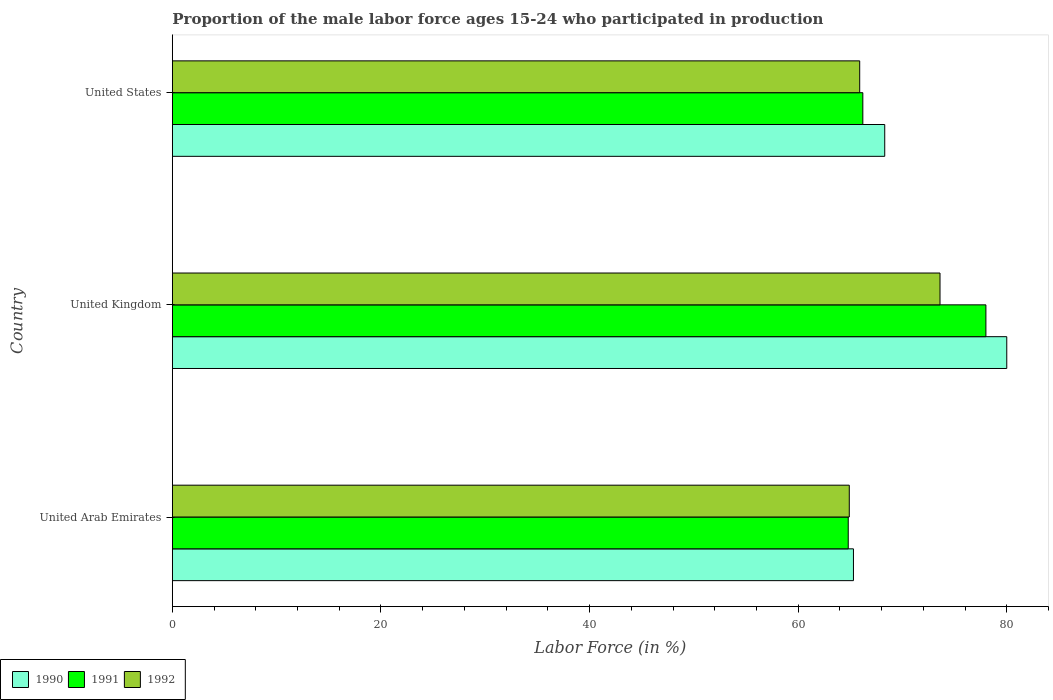How many different coloured bars are there?
Make the answer very short. 3. How many groups of bars are there?
Provide a succinct answer. 3. Are the number of bars per tick equal to the number of legend labels?
Provide a short and direct response. Yes. Are the number of bars on each tick of the Y-axis equal?
Provide a succinct answer. Yes. How many bars are there on the 3rd tick from the top?
Your answer should be compact. 3. What is the label of the 2nd group of bars from the top?
Provide a short and direct response. United Kingdom. In how many cases, is the number of bars for a given country not equal to the number of legend labels?
Provide a short and direct response. 0. Across all countries, what is the maximum proportion of the male labor force who participated in production in 1991?
Give a very brief answer. 78. Across all countries, what is the minimum proportion of the male labor force who participated in production in 1990?
Keep it short and to the point. 65.3. In which country was the proportion of the male labor force who participated in production in 1992 minimum?
Ensure brevity in your answer.  United Arab Emirates. What is the total proportion of the male labor force who participated in production in 1990 in the graph?
Your answer should be compact. 213.6. What is the difference between the proportion of the male labor force who participated in production in 1991 in United Arab Emirates and that in United States?
Provide a succinct answer. -1.4. What is the difference between the proportion of the male labor force who participated in production in 1991 in United Kingdom and the proportion of the male labor force who participated in production in 1992 in United States?
Your answer should be compact. 12.1. What is the average proportion of the male labor force who participated in production in 1992 per country?
Provide a succinct answer. 68.13. What is the difference between the proportion of the male labor force who participated in production in 1992 and proportion of the male labor force who participated in production in 1991 in United States?
Your response must be concise. -0.3. What is the ratio of the proportion of the male labor force who participated in production in 1990 in United Arab Emirates to that in United Kingdom?
Ensure brevity in your answer.  0.82. Is the difference between the proportion of the male labor force who participated in production in 1992 in United Arab Emirates and United States greater than the difference between the proportion of the male labor force who participated in production in 1991 in United Arab Emirates and United States?
Offer a very short reply. Yes. What is the difference between the highest and the second highest proportion of the male labor force who participated in production in 1991?
Provide a short and direct response. 11.8. What is the difference between the highest and the lowest proportion of the male labor force who participated in production in 1991?
Offer a very short reply. 13.2. What does the 1st bar from the bottom in United Arab Emirates represents?
Offer a terse response. 1990. Is it the case that in every country, the sum of the proportion of the male labor force who participated in production in 1992 and proportion of the male labor force who participated in production in 1990 is greater than the proportion of the male labor force who participated in production in 1991?
Your answer should be very brief. Yes. Are all the bars in the graph horizontal?
Offer a very short reply. Yes. What is the difference between two consecutive major ticks on the X-axis?
Your response must be concise. 20. Are the values on the major ticks of X-axis written in scientific E-notation?
Your response must be concise. No. Does the graph contain any zero values?
Provide a succinct answer. No. Does the graph contain grids?
Your answer should be compact. No. Where does the legend appear in the graph?
Ensure brevity in your answer.  Bottom left. How many legend labels are there?
Keep it short and to the point. 3. What is the title of the graph?
Keep it short and to the point. Proportion of the male labor force ages 15-24 who participated in production. What is the label or title of the X-axis?
Provide a succinct answer. Labor Force (in %). What is the label or title of the Y-axis?
Provide a short and direct response. Country. What is the Labor Force (in %) in 1990 in United Arab Emirates?
Make the answer very short. 65.3. What is the Labor Force (in %) of 1991 in United Arab Emirates?
Your response must be concise. 64.8. What is the Labor Force (in %) in 1992 in United Arab Emirates?
Your answer should be compact. 64.9. What is the Labor Force (in %) in 1991 in United Kingdom?
Your answer should be compact. 78. What is the Labor Force (in %) in 1992 in United Kingdom?
Your answer should be compact. 73.6. What is the Labor Force (in %) in 1990 in United States?
Your response must be concise. 68.3. What is the Labor Force (in %) of 1991 in United States?
Keep it short and to the point. 66.2. What is the Labor Force (in %) of 1992 in United States?
Provide a short and direct response. 65.9. Across all countries, what is the maximum Labor Force (in %) in 1992?
Provide a succinct answer. 73.6. Across all countries, what is the minimum Labor Force (in %) in 1990?
Offer a very short reply. 65.3. Across all countries, what is the minimum Labor Force (in %) of 1991?
Provide a succinct answer. 64.8. Across all countries, what is the minimum Labor Force (in %) of 1992?
Your answer should be compact. 64.9. What is the total Labor Force (in %) in 1990 in the graph?
Keep it short and to the point. 213.6. What is the total Labor Force (in %) in 1991 in the graph?
Provide a succinct answer. 209. What is the total Labor Force (in %) of 1992 in the graph?
Keep it short and to the point. 204.4. What is the difference between the Labor Force (in %) of 1990 in United Arab Emirates and that in United Kingdom?
Make the answer very short. -14.7. What is the difference between the Labor Force (in %) of 1991 in United Arab Emirates and that in United Kingdom?
Give a very brief answer. -13.2. What is the difference between the Labor Force (in %) of 1991 in United Kingdom and that in United States?
Give a very brief answer. 11.8. What is the difference between the Labor Force (in %) in 1990 in United Arab Emirates and the Labor Force (in %) in 1991 in United Kingdom?
Make the answer very short. -12.7. What is the difference between the Labor Force (in %) in 1990 in United Arab Emirates and the Labor Force (in %) in 1992 in United Kingdom?
Provide a short and direct response. -8.3. What is the difference between the Labor Force (in %) of 1990 in United Arab Emirates and the Labor Force (in %) of 1991 in United States?
Give a very brief answer. -0.9. What is the difference between the Labor Force (in %) of 1991 in United Arab Emirates and the Labor Force (in %) of 1992 in United States?
Your answer should be compact. -1.1. What is the average Labor Force (in %) of 1990 per country?
Ensure brevity in your answer.  71.2. What is the average Labor Force (in %) in 1991 per country?
Offer a very short reply. 69.67. What is the average Labor Force (in %) in 1992 per country?
Provide a succinct answer. 68.13. What is the difference between the Labor Force (in %) of 1990 and Labor Force (in %) of 1991 in United Arab Emirates?
Offer a terse response. 0.5. What is the difference between the Labor Force (in %) of 1990 and Labor Force (in %) of 1992 in United Arab Emirates?
Provide a short and direct response. 0.4. What is the difference between the Labor Force (in %) of 1991 and Labor Force (in %) of 1992 in United Arab Emirates?
Make the answer very short. -0.1. What is the difference between the Labor Force (in %) in 1990 and Labor Force (in %) in 1991 in United Kingdom?
Give a very brief answer. 2. What is the difference between the Labor Force (in %) in 1990 and Labor Force (in %) in 1991 in United States?
Your answer should be compact. 2.1. What is the ratio of the Labor Force (in %) in 1990 in United Arab Emirates to that in United Kingdom?
Make the answer very short. 0.82. What is the ratio of the Labor Force (in %) of 1991 in United Arab Emirates to that in United Kingdom?
Make the answer very short. 0.83. What is the ratio of the Labor Force (in %) of 1992 in United Arab Emirates to that in United Kingdom?
Your answer should be compact. 0.88. What is the ratio of the Labor Force (in %) of 1990 in United Arab Emirates to that in United States?
Offer a terse response. 0.96. What is the ratio of the Labor Force (in %) of 1991 in United Arab Emirates to that in United States?
Keep it short and to the point. 0.98. What is the ratio of the Labor Force (in %) in 1992 in United Arab Emirates to that in United States?
Offer a terse response. 0.98. What is the ratio of the Labor Force (in %) of 1990 in United Kingdom to that in United States?
Give a very brief answer. 1.17. What is the ratio of the Labor Force (in %) of 1991 in United Kingdom to that in United States?
Provide a short and direct response. 1.18. What is the ratio of the Labor Force (in %) of 1992 in United Kingdom to that in United States?
Make the answer very short. 1.12. What is the difference between the highest and the second highest Labor Force (in %) in 1990?
Your answer should be very brief. 11.7. What is the difference between the highest and the lowest Labor Force (in %) of 1990?
Your answer should be compact. 14.7. 